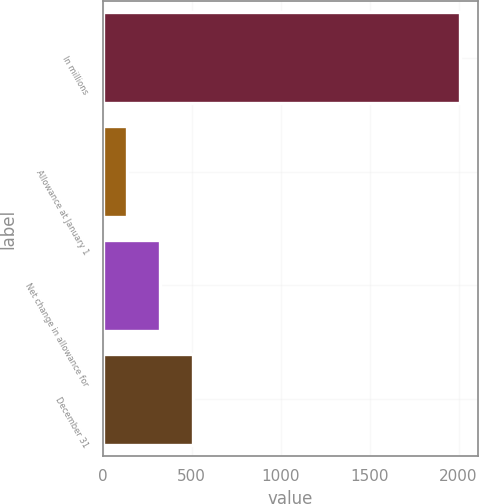<chart> <loc_0><loc_0><loc_500><loc_500><bar_chart><fcel>In millions<fcel>Allowance at January 1<fcel>Net change in allowance for<fcel>December 31<nl><fcel>2008<fcel>134<fcel>321.4<fcel>508.8<nl></chart> 